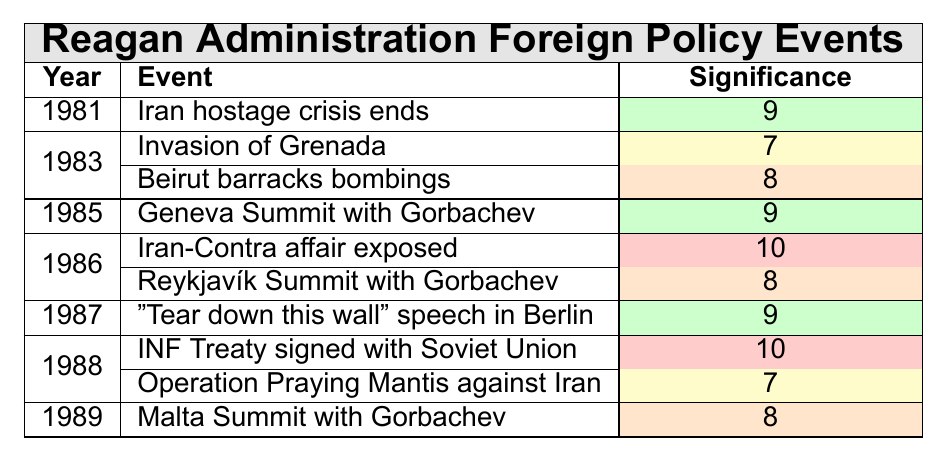What year did the Iran hostage crisis end? According to the table, the Iran hostage crisis ended in the year 1981.
Answer: 1981 Which event has the highest significance rating? The Iran-Contra affair exposed in 1986 has the highest significance rating of 10.
Answer: Iran-Contra affair exposed How many events occurred in 1986? The table lists two events for the year 1986: the Iran-Contra affair exposed and the Reykjavík Summit with Gorbachev.
Answer: 2 What is the average significance rating of events from the year 1988? There are two events in 1988 with significance ratings of 10 and 7. Summing these gives 10 + 7 = 17. To find the average, divide by the number of events (2), so 17 / 2 = 8.5.
Answer: 8.5 Did the U.S. invade Grenada under the Reagan administration? Yes, the table lists the Invasion of Grenada as an event in 1983, confirming that it occurred under Reagan's administration.
Answer: Yes Which year had the most significant event and what was it? The most significant event was the Iran-Contra affair exposed in 1986, which has a significance rating of 10.
Answer: 1986, Iran-Contra affair exposed What is the total significance rating of all events that occurred in 1983? In 1983, there are two events: the Invasion of Grenada (significance 7) and the Beirut barracks bombings (significance 8). Summing these gives 7 + 8 = 15.
Answer: 15 Which event was associated with a significant speech in 1987? The table indicates that the event associated with a significant speech in 1987 was "Tear down this wall" speech in Berlin.
Answer: Tear down this wall speech in Berlin Is there a pattern in significance ratings across the years listed? By analyzing the significance ratings, we see fluctuations: 9 (1981), 7 & 8 (1983), 9 (1985), 10 & 8 (1986), 9 (1987), 10 & 7 (1988), and 8 (1989), indicating varied importance across the years.
Answer: Yes What was the significance rating of the Geneva Summit with Gorbachev? The Geneva Summit with Gorbachev, which occurred in 1985, has a significance rating of 9 according to the table.
Answer: 9 